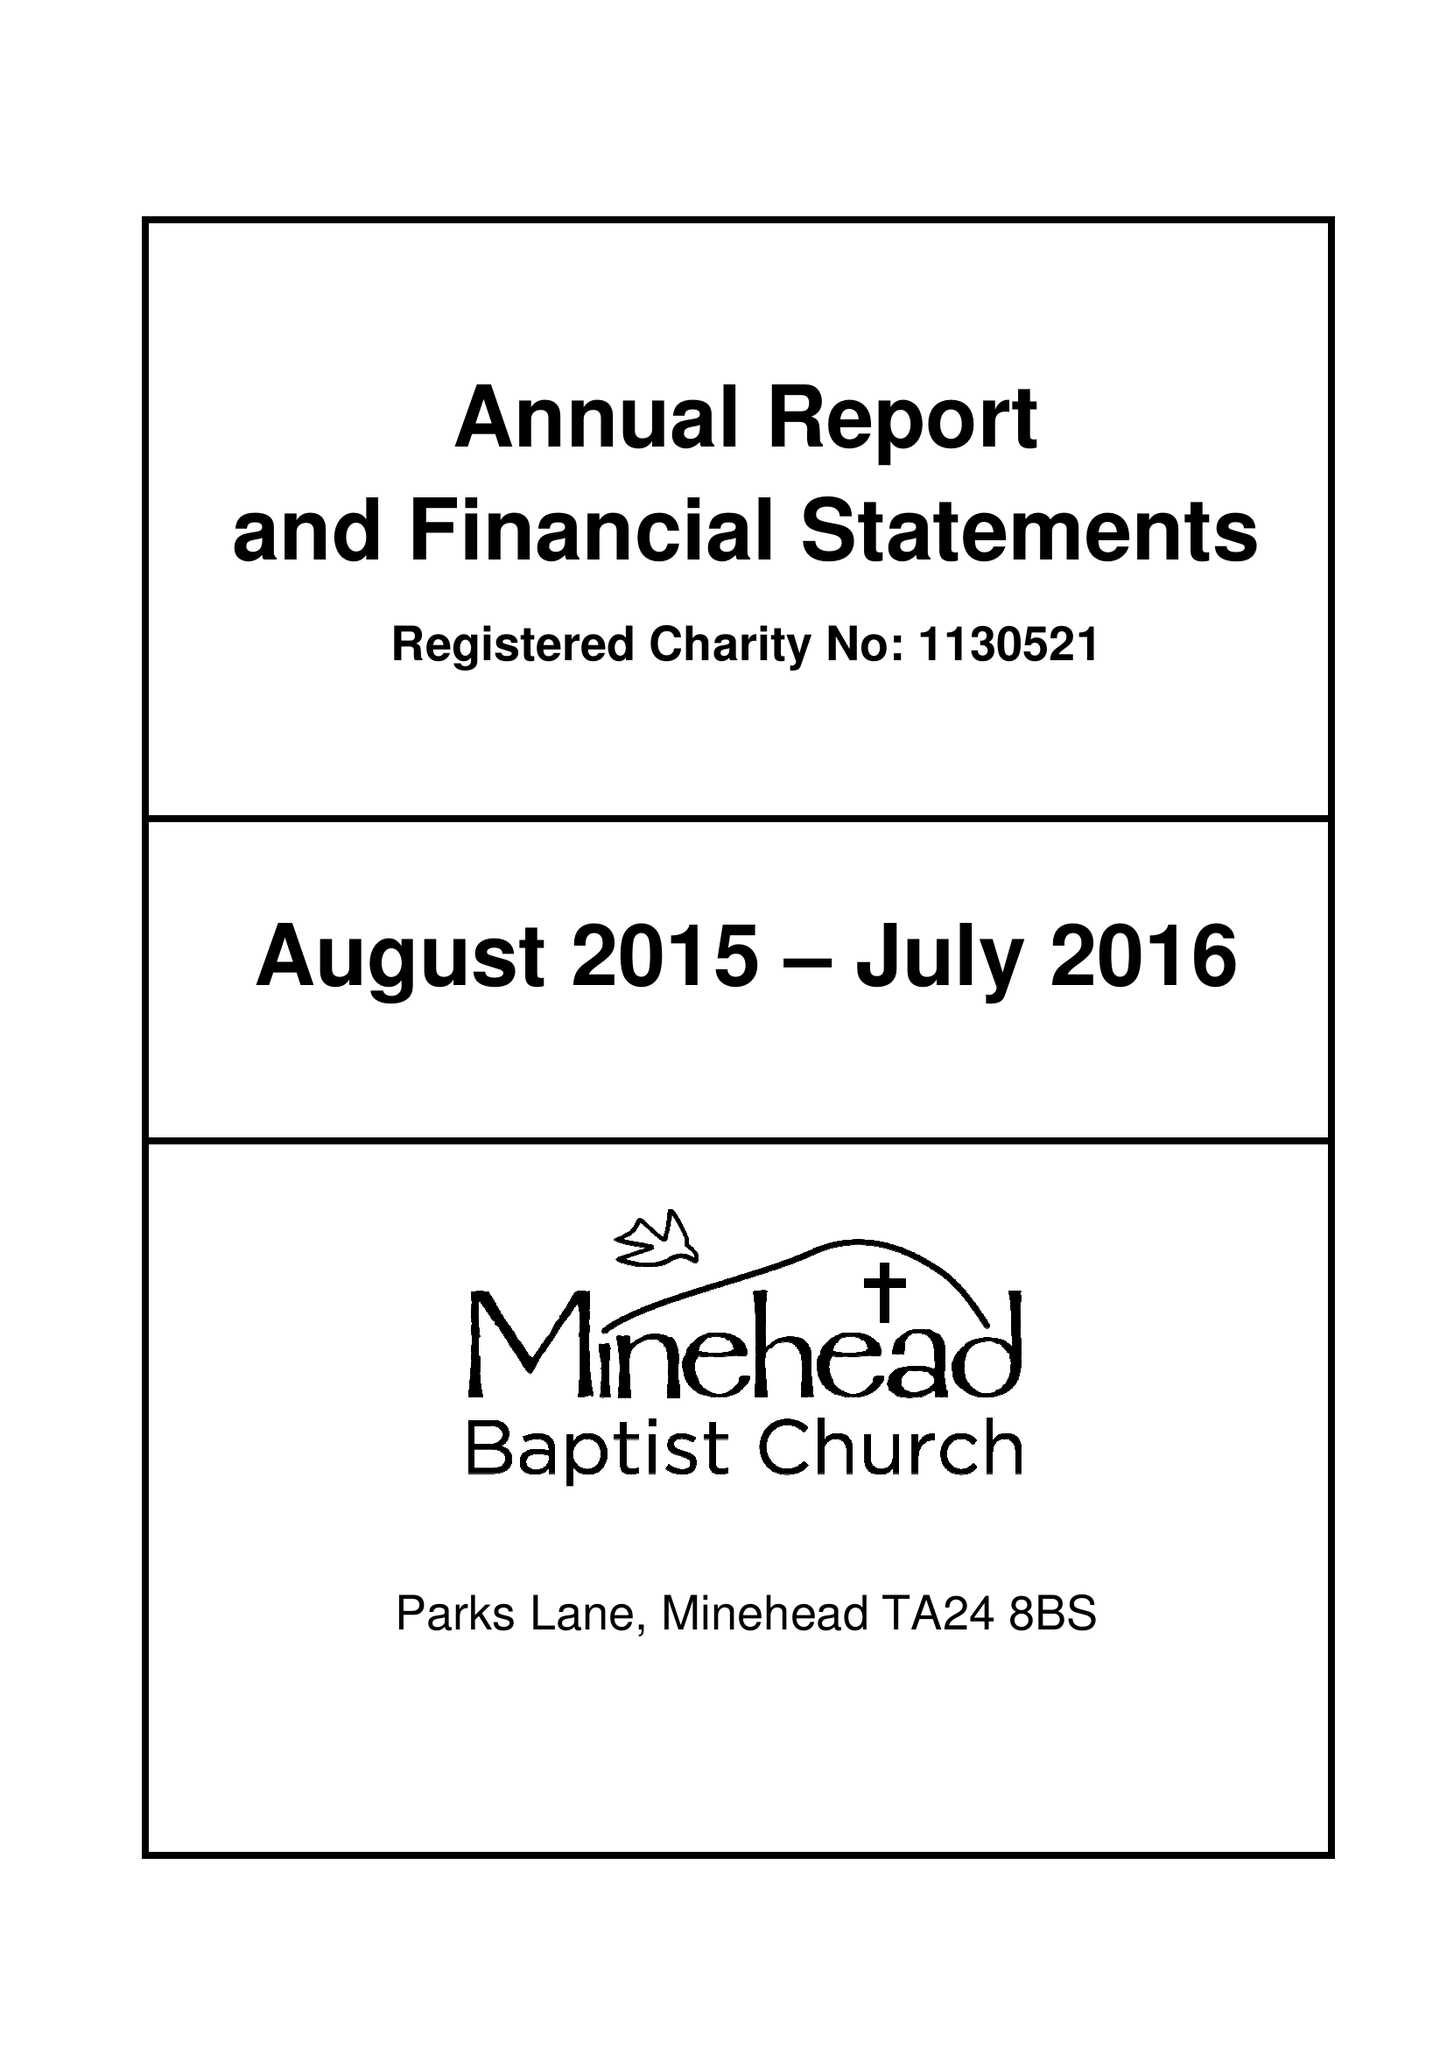What is the value for the address__postcode?
Answer the question using a single word or phrase. TA24 8BS 